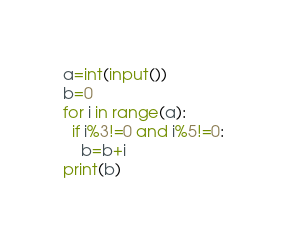<code> <loc_0><loc_0><loc_500><loc_500><_Python_>a=int(input())
b=0
for i in range(a):
  if i%3!=0 and i%5!=0:
    b=b+i
print(b)</code> 